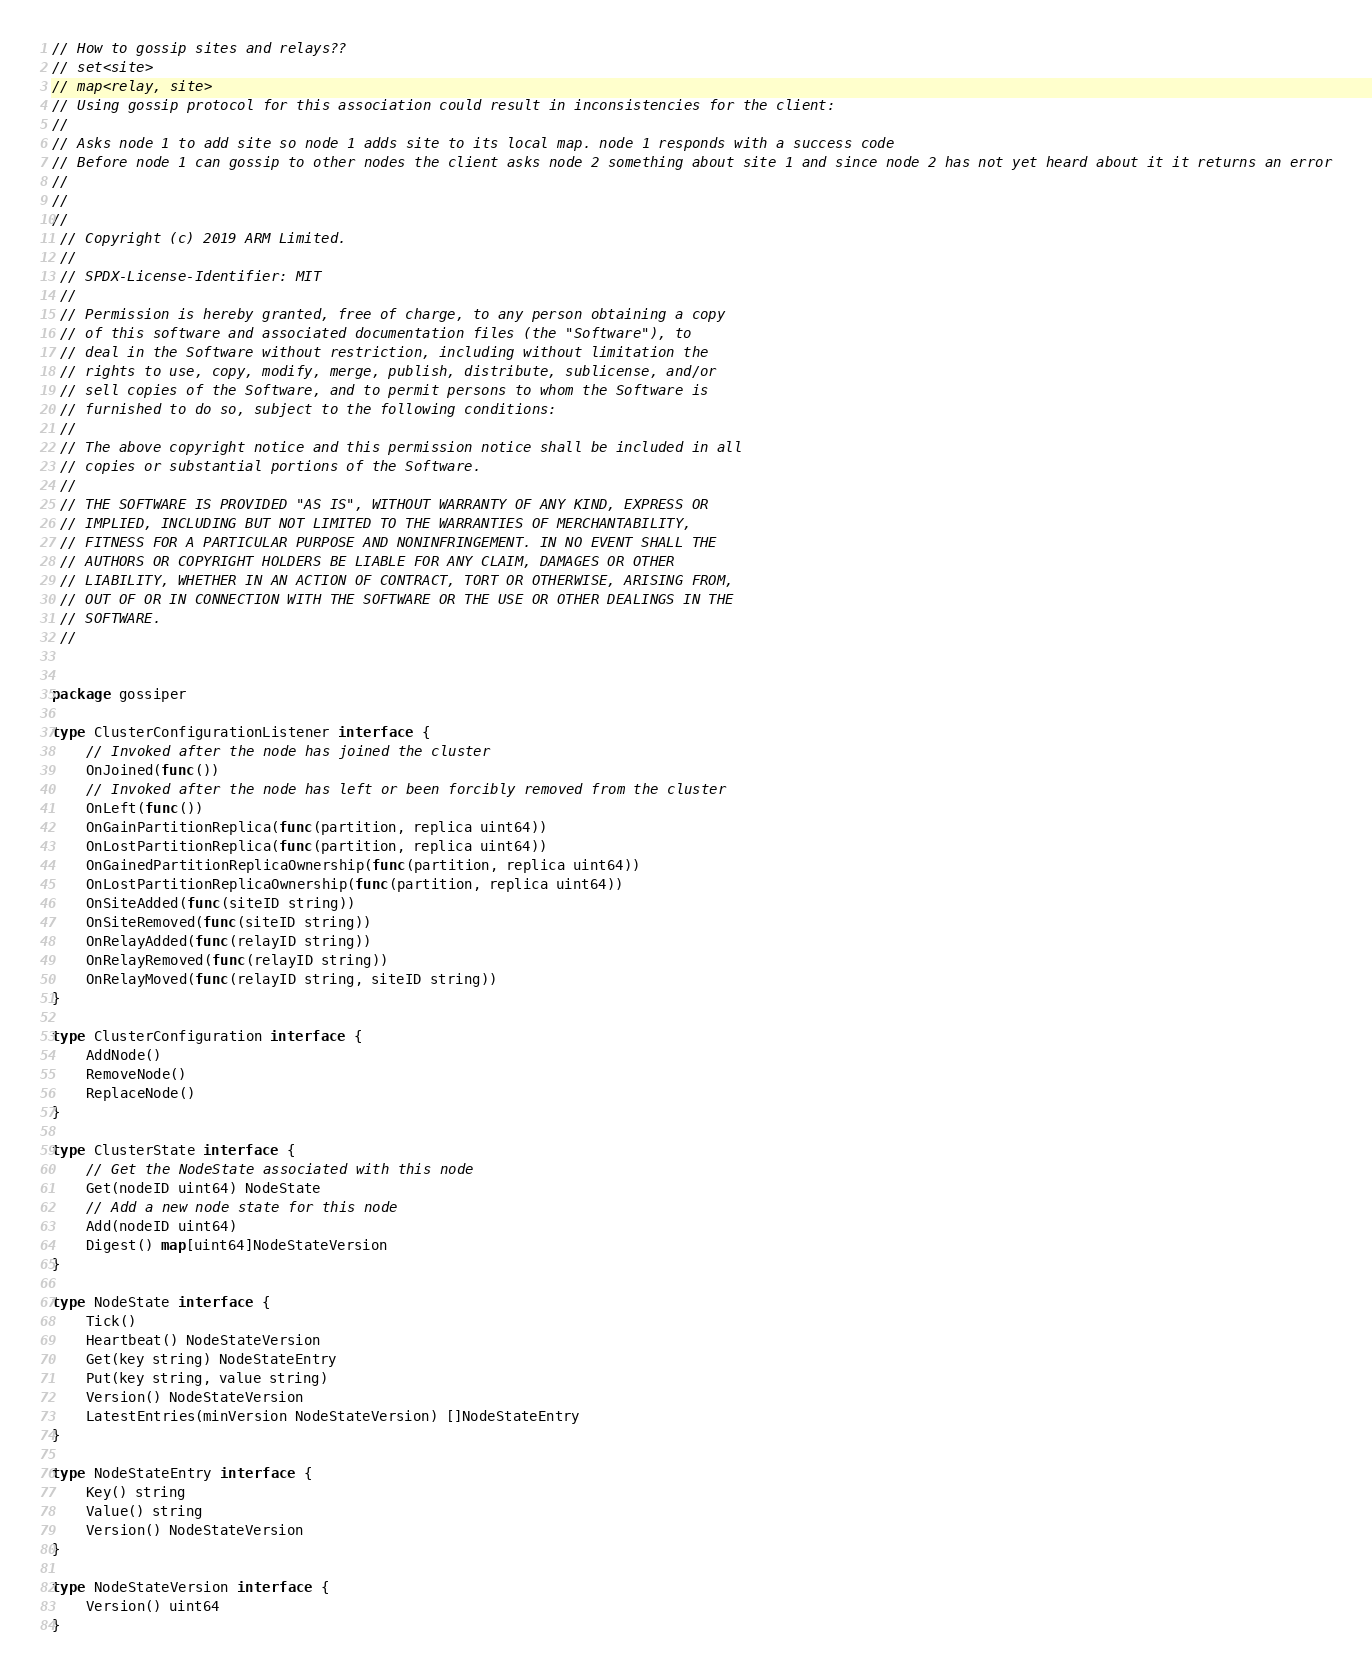<code> <loc_0><loc_0><loc_500><loc_500><_Go_>// How to gossip sites and relays??
// set<site>
// map<relay, site>
// Using gossip protocol for this association could result in inconsistencies for the client:
//
// Asks node 1 to add site so node 1 adds site to its local map. node 1 responds with a success code
// Before node 1 can gossip to other nodes the client asks node 2 something about site 1 and since node 2 has not yet heard about it it returns an error
// 
// 
//
 // Copyright (c) 2019 ARM Limited.
 //
 // SPDX-License-Identifier: MIT
 //
 // Permission is hereby granted, free of charge, to any person obtaining a copy
 // of this software and associated documentation files (the "Software"), to
 // deal in the Software without restriction, including without limitation the
 // rights to use, copy, modify, merge, publish, distribute, sublicense, and/or
 // sell copies of the Software, and to permit persons to whom the Software is
 // furnished to do so, subject to the following conditions:
 //
 // The above copyright notice and this permission notice shall be included in all
 // copies or substantial portions of the Software.
 //
 // THE SOFTWARE IS PROVIDED "AS IS", WITHOUT WARRANTY OF ANY KIND, EXPRESS OR
 // IMPLIED, INCLUDING BUT NOT LIMITED TO THE WARRANTIES OF MERCHANTABILITY,
 // FITNESS FOR A PARTICULAR PURPOSE AND NONINFRINGEMENT. IN NO EVENT SHALL THE
 // AUTHORS OR COPYRIGHT HOLDERS BE LIABLE FOR ANY CLAIM, DAMAGES OR OTHER
 // LIABILITY, WHETHER IN AN ACTION OF CONTRACT, TORT OR OTHERWISE, ARISING FROM,
 // OUT OF OR IN CONNECTION WITH THE SOFTWARE OR THE USE OR OTHER DEALINGS IN THE
 // SOFTWARE.
 //


package gossiper

type ClusterConfigurationListener interface {
    // Invoked after the node has joined the cluster
    OnJoined(func())
    // Invoked after the node has left or been forcibly removed from the cluster
    OnLeft(func())
    OnGainPartitionReplica(func(partition, replica uint64))
    OnLostPartitionReplica(func(partition, replica uint64))
    OnGainedPartitionReplicaOwnership(func(partition, replica uint64))
    OnLostPartitionReplicaOwnership(func(partition, replica uint64))
    OnSiteAdded(func(siteID string))
    OnSiteRemoved(func(siteID string))
    OnRelayAdded(func(relayID string))
    OnRelayRemoved(func(relayID string))
    OnRelayMoved(func(relayID string, siteID string))
}

type ClusterConfiguration interface {
    AddNode()
    RemoveNode()
    ReplaceNode()
}

type ClusterState interface {
    // Get the NodeState associated with this node
    Get(nodeID uint64) NodeState
    // Add a new node state for this node
    Add(nodeID uint64)
    Digest() map[uint64]NodeStateVersion
}

type NodeState interface {
    Tick()
    Heartbeat() NodeStateVersion
    Get(key string) NodeStateEntry
    Put(key string, value string)
    Version() NodeStateVersion
    LatestEntries(minVersion NodeStateVersion) []NodeStateEntry
}

type NodeStateEntry interface {
    Key() string
    Value() string
    Version() NodeStateVersion
}

type NodeStateVersion interface {
    Version() uint64
}</code> 